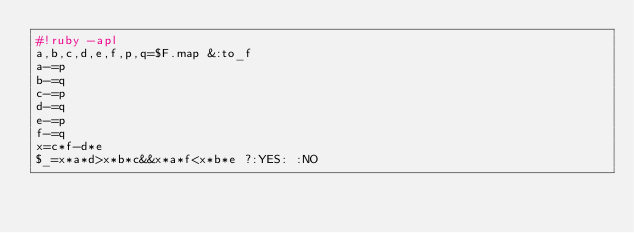<code> <loc_0><loc_0><loc_500><loc_500><_Ruby_>#!ruby -apl
a,b,c,d,e,f,p,q=$F.map &:to_f
a-=p
b-=q
c-=p
d-=q
e-=p
f-=q
x=c*f-d*e
$_=x*a*d>x*b*c&&x*a*f<x*b*e ?:YES: :NO</code> 